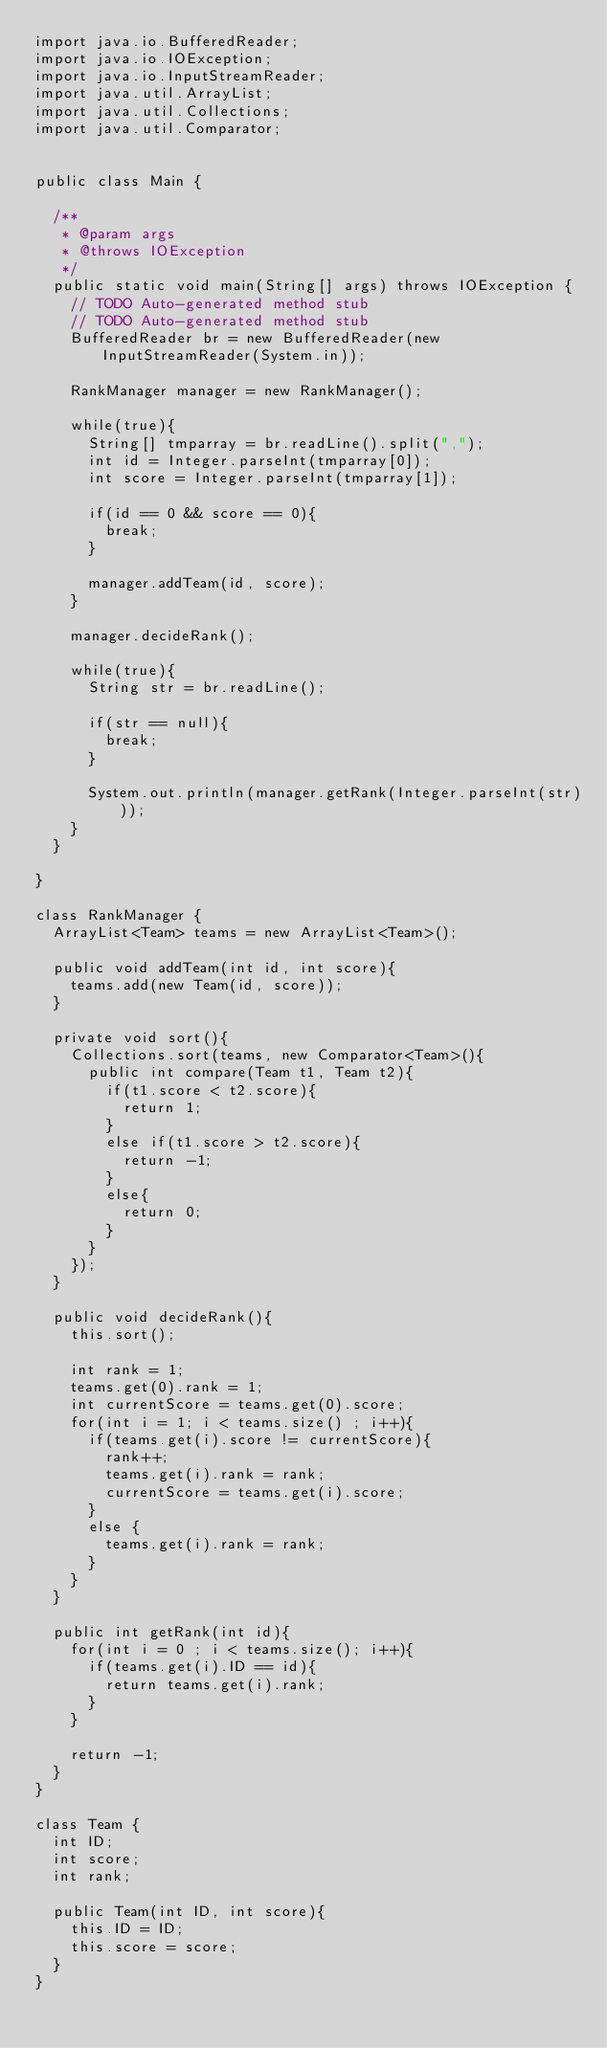<code> <loc_0><loc_0><loc_500><loc_500><_Java_>import java.io.BufferedReader;
import java.io.IOException;
import java.io.InputStreamReader;
import java.util.ArrayList;
import java.util.Collections;
import java.util.Comparator;


public class Main {

	/**
	 * @param args
	 * @throws IOException 
	 */
	public static void main(String[] args) throws IOException {
		// TODO Auto-generated method stub
		// TODO Auto-generated method stub
		BufferedReader br = new BufferedReader(new InputStreamReader(System.in));

		RankManager manager = new RankManager();
		
		while(true){
			String[] tmparray = br.readLine().split(",");
			int id = Integer.parseInt(tmparray[0]);
			int score = Integer.parseInt(tmparray[1]);
			
			if(id == 0 && score == 0){
				break;
			}
			
			manager.addTeam(id, score);
		}
		
		manager.decideRank();
		
		while(true){
			String str = br.readLine();
			
			if(str == null){
				break;
			}
			
			System.out.println(manager.getRank(Integer.parseInt(str)));
		}
	}

}

class RankManager {
	ArrayList<Team> teams = new ArrayList<Team>();

	public void addTeam(int id, int score){
		teams.add(new Team(id, score));
	}

	private void sort(){
		Collections.sort(teams, new Comparator<Team>(){
			public int compare(Team t1, Team t2){
				if(t1.score < t2.score){
					return 1;
				}
				else if(t1.score > t2.score){
					return -1;
				}
				else{
					return 0;
				}
			}
		});
	}

	public void decideRank(){
		this.sort();

		int rank = 1;
		teams.get(0).rank = 1;
		int currentScore = teams.get(0).score;
		for(int i = 1; i < teams.size() ; i++){
			if(teams.get(i).score != currentScore){
				rank++;
				teams.get(i).rank = rank;
				currentScore = teams.get(i).score;
			}
			else {
				teams.get(i).rank = rank;
			}
		}
	}

	public int getRank(int id){
		for(int i = 0 ; i < teams.size(); i++){
			if(teams.get(i).ID == id){
				return teams.get(i).rank;
			}
		}
		
		return -1;
	}
}

class Team {
	int ID;
	int score;
	int rank;

	public Team(int ID, int score){
		this.ID = ID;
		this.score = score;
	}
}</code> 